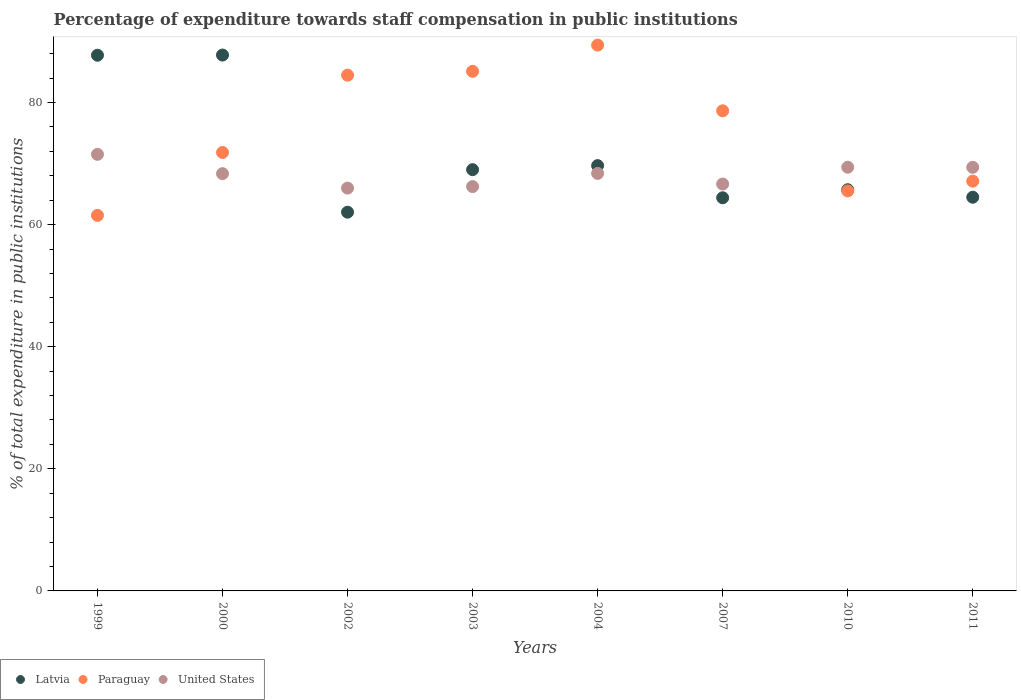How many different coloured dotlines are there?
Your response must be concise. 3. What is the percentage of expenditure towards staff compensation in Latvia in 1999?
Offer a very short reply. 87.75. Across all years, what is the maximum percentage of expenditure towards staff compensation in United States?
Your answer should be compact. 71.52. Across all years, what is the minimum percentage of expenditure towards staff compensation in Paraguay?
Keep it short and to the point. 61.52. In which year was the percentage of expenditure towards staff compensation in Latvia maximum?
Your response must be concise. 2000. In which year was the percentage of expenditure towards staff compensation in United States minimum?
Keep it short and to the point. 2002. What is the total percentage of expenditure towards staff compensation in Paraguay in the graph?
Your response must be concise. 603.67. What is the difference between the percentage of expenditure towards staff compensation in United States in 2004 and that in 2011?
Make the answer very short. -1. What is the difference between the percentage of expenditure towards staff compensation in Paraguay in 2000 and the percentage of expenditure towards staff compensation in Latvia in 2007?
Keep it short and to the point. 7.42. What is the average percentage of expenditure towards staff compensation in Paraguay per year?
Your response must be concise. 75.46. In the year 2002, what is the difference between the percentage of expenditure towards staff compensation in Paraguay and percentage of expenditure towards staff compensation in Latvia?
Offer a terse response. 22.44. What is the ratio of the percentage of expenditure towards staff compensation in Paraguay in 2003 to that in 2011?
Make the answer very short. 1.27. What is the difference between the highest and the second highest percentage of expenditure towards staff compensation in United States?
Your answer should be compact. 2.11. What is the difference between the highest and the lowest percentage of expenditure towards staff compensation in United States?
Provide a short and direct response. 5.53. In how many years, is the percentage of expenditure towards staff compensation in Latvia greater than the average percentage of expenditure towards staff compensation in Latvia taken over all years?
Make the answer very short. 2. Is it the case that in every year, the sum of the percentage of expenditure towards staff compensation in United States and percentage of expenditure towards staff compensation in Paraguay  is greater than the percentage of expenditure towards staff compensation in Latvia?
Offer a very short reply. Yes. Is the percentage of expenditure towards staff compensation in Paraguay strictly greater than the percentage of expenditure towards staff compensation in Latvia over the years?
Offer a terse response. No. How many dotlines are there?
Keep it short and to the point. 3. How many years are there in the graph?
Give a very brief answer. 8. What is the difference between two consecutive major ticks on the Y-axis?
Provide a short and direct response. 20. Are the values on the major ticks of Y-axis written in scientific E-notation?
Make the answer very short. No. Does the graph contain any zero values?
Your response must be concise. No. Where does the legend appear in the graph?
Your response must be concise. Bottom left. How are the legend labels stacked?
Your response must be concise. Horizontal. What is the title of the graph?
Provide a succinct answer. Percentage of expenditure towards staff compensation in public institutions. Does "Afghanistan" appear as one of the legend labels in the graph?
Give a very brief answer. No. What is the label or title of the Y-axis?
Offer a terse response. % of total expenditure in public institutions. What is the % of total expenditure in public institutions of Latvia in 1999?
Your answer should be compact. 87.75. What is the % of total expenditure in public institutions in Paraguay in 1999?
Offer a terse response. 61.52. What is the % of total expenditure in public institutions of United States in 1999?
Offer a terse response. 71.52. What is the % of total expenditure in public institutions in Latvia in 2000?
Keep it short and to the point. 87.78. What is the % of total expenditure in public institutions of Paraguay in 2000?
Your answer should be very brief. 71.82. What is the % of total expenditure in public institutions of United States in 2000?
Your answer should be compact. 68.35. What is the % of total expenditure in public institutions in Latvia in 2002?
Keep it short and to the point. 62.04. What is the % of total expenditure in public institutions in Paraguay in 2002?
Provide a short and direct response. 84.49. What is the % of total expenditure in public institutions in United States in 2002?
Make the answer very short. 65.98. What is the % of total expenditure in public institutions in Latvia in 2003?
Provide a succinct answer. 69.01. What is the % of total expenditure in public institutions in Paraguay in 2003?
Ensure brevity in your answer.  85.12. What is the % of total expenditure in public institutions of United States in 2003?
Make the answer very short. 66.24. What is the % of total expenditure in public institutions of Latvia in 2004?
Provide a succinct answer. 69.67. What is the % of total expenditure in public institutions in Paraguay in 2004?
Give a very brief answer. 89.41. What is the % of total expenditure in public institutions in United States in 2004?
Provide a succinct answer. 68.39. What is the % of total expenditure in public institutions of Latvia in 2007?
Offer a terse response. 64.4. What is the % of total expenditure in public institutions of Paraguay in 2007?
Offer a very short reply. 78.65. What is the % of total expenditure in public institutions in United States in 2007?
Offer a terse response. 66.65. What is the % of total expenditure in public institutions of Latvia in 2010?
Give a very brief answer. 65.72. What is the % of total expenditure in public institutions of Paraguay in 2010?
Offer a terse response. 65.53. What is the % of total expenditure in public institutions in United States in 2010?
Provide a short and direct response. 69.4. What is the % of total expenditure in public institutions of Latvia in 2011?
Provide a short and direct response. 64.49. What is the % of total expenditure in public institutions in Paraguay in 2011?
Provide a short and direct response. 67.13. What is the % of total expenditure in public institutions of United States in 2011?
Give a very brief answer. 69.39. Across all years, what is the maximum % of total expenditure in public institutions in Latvia?
Your response must be concise. 87.78. Across all years, what is the maximum % of total expenditure in public institutions in Paraguay?
Make the answer very short. 89.41. Across all years, what is the maximum % of total expenditure in public institutions of United States?
Your answer should be very brief. 71.52. Across all years, what is the minimum % of total expenditure in public institutions in Latvia?
Make the answer very short. 62.04. Across all years, what is the minimum % of total expenditure in public institutions of Paraguay?
Provide a succinct answer. 61.52. Across all years, what is the minimum % of total expenditure in public institutions of United States?
Your answer should be compact. 65.98. What is the total % of total expenditure in public institutions of Latvia in the graph?
Keep it short and to the point. 570.88. What is the total % of total expenditure in public institutions of Paraguay in the graph?
Provide a succinct answer. 603.67. What is the total % of total expenditure in public institutions in United States in the graph?
Provide a succinct answer. 545.93. What is the difference between the % of total expenditure in public institutions of Latvia in 1999 and that in 2000?
Make the answer very short. -0.03. What is the difference between the % of total expenditure in public institutions in Paraguay in 1999 and that in 2000?
Make the answer very short. -10.3. What is the difference between the % of total expenditure in public institutions in United States in 1999 and that in 2000?
Your answer should be compact. 3.16. What is the difference between the % of total expenditure in public institutions of Latvia in 1999 and that in 2002?
Give a very brief answer. 25.71. What is the difference between the % of total expenditure in public institutions in Paraguay in 1999 and that in 2002?
Provide a succinct answer. -22.97. What is the difference between the % of total expenditure in public institutions of United States in 1999 and that in 2002?
Give a very brief answer. 5.53. What is the difference between the % of total expenditure in public institutions of Latvia in 1999 and that in 2003?
Ensure brevity in your answer.  18.74. What is the difference between the % of total expenditure in public institutions in Paraguay in 1999 and that in 2003?
Ensure brevity in your answer.  -23.6. What is the difference between the % of total expenditure in public institutions in United States in 1999 and that in 2003?
Offer a very short reply. 5.28. What is the difference between the % of total expenditure in public institutions in Latvia in 1999 and that in 2004?
Offer a very short reply. 18.08. What is the difference between the % of total expenditure in public institutions in Paraguay in 1999 and that in 2004?
Your answer should be very brief. -27.9. What is the difference between the % of total expenditure in public institutions of United States in 1999 and that in 2004?
Your response must be concise. 3.12. What is the difference between the % of total expenditure in public institutions of Latvia in 1999 and that in 2007?
Keep it short and to the point. 23.35. What is the difference between the % of total expenditure in public institutions of Paraguay in 1999 and that in 2007?
Keep it short and to the point. -17.13. What is the difference between the % of total expenditure in public institutions of United States in 1999 and that in 2007?
Keep it short and to the point. 4.86. What is the difference between the % of total expenditure in public institutions in Latvia in 1999 and that in 2010?
Offer a very short reply. 22.03. What is the difference between the % of total expenditure in public institutions of Paraguay in 1999 and that in 2010?
Make the answer very short. -4.01. What is the difference between the % of total expenditure in public institutions of United States in 1999 and that in 2010?
Ensure brevity in your answer.  2.11. What is the difference between the % of total expenditure in public institutions in Latvia in 1999 and that in 2011?
Ensure brevity in your answer.  23.26. What is the difference between the % of total expenditure in public institutions in Paraguay in 1999 and that in 2011?
Offer a terse response. -5.61. What is the difference between the % of total expenditure in public institutions in United States in 1999 and that in 2011?
Your response must be concise. 2.12. What is the difference between the % of total expenditure in public institutions in Latvia in 2000 and that in 2002?
Keep it short and to the point. 25.74. What is the difference between the % of total expenditure in public institutions of Paraguay in 2000 and that in 2002?
Offer a very short reply. -12.67. What is the difference between the % of total expenditure in public institutions of United States in 2000 and that in 2002?
Your answer should be very brief. 2.37. What is the difference between the % of total expenditure in public institutions in Latvia in 2000 and that in 2003?
Offer a very short reply. 18.77. What is the difference between the % of total expenditure in public institutions of Paraguay in 2000 and that in 2003?
Give a very brief answer. -13.3. What is the difference between the % of total expenditure in public institutions of United States in 2000 and that in 2003?
Make the answer very short. 2.11. What is the difference between the % of total expenditure in public institutions in Latvia in 2000 and that in 2004?
Provide a short and direct response. 18.11. What is the difference between the % of total expenditure in public institutions in Paraguay in 2000 and that in 2004?
Provide a short and direct response. -17.59. What is the difference between the % of total expenditure in public institutions of United States in 2000 and that in 2004?
Keep it short and to the point. -0.04. What is the difference between the % of total expenditure in public institutions in Latvia in 2000 and that in 2007?
Your response must be concise. 23.38. What is the difference between the % of total expenditure in public institutions of Paraguay in 2000 and that in 2007?
Your answer should be compact. -6.83. What is the difference between the % of total expenditure in public institutions in United States in 2000 and that in 2007?
Offer a very short reply. 1.7. What is the difference between the % of total expenditure in public institutions in Latvia in 2000 and that in 2010?
Make the answer very short. 22.06. What is the difference between the % of total expenditure in public institutions of Paraguay in 2000 and that in 2010?
Offer a terse response. 6.29. What is the difference between the % of total expenditure in public institutions in United States in 2000 and that in 2010?
Provide a succinct answer. -1.05. What is the difference between the % of total expenditure in public institutions of Latvia in 2000 and that in 2011?
Make the answer very short. 23.29. What is the difference between the % of total expenditure in public institutions in Paraguay in 2000 and that in 2011?
Give a very brief answer. 4.69. What is the difference between the % of total expenditure in public institutions in United States in 2000 and that in 2011?
Your answer should be very brief. -1.04. What is the difference between the % of total expenditure in public institutions of Latvia in 2002 and that in 2003?
Give a very brief answer. -6.97. What is the difference between the % of total expenditure in public institutions of Paraguay in 2002 and that in 2003?
Offer a very short reply. -0.63. What is the difference between the % of total expenditure in public institutions of United States in 2002 and that in 2003?
Offer a terse response. -0.25. What is the difference between the % of total expenditure in public institutions of Latvia in 2002 and that in 2004?
Your answer should be very brief. -7.63. What is the difference between the % of total expenditure in public institutions of Paraguay in 2002 and that in 2004?
Provide a short and direct response. -4.93. What is the difference between the % of total expenditure in public institutions of United States in 2002 and that in 2004?
Provide a succinct answer. -2.41. What is the difference between the % of total expenditure in public institutions of Latvia in 2002 and that in 2007?
Offer a very short reply. -2.36. What is the difference between the % of total expenditure in public institutions in Paraguay in 2002 and that in 2007?
Provide a short and direct response. 5.84. What is the difference between the % of total expenditure in public institutions in United States in 2002 and that in 2007?
Ensure brevity in your answer.  -0.67. What is the difference between the % of total expenditure in public institutions of Latvia in 2002 and that in 2010?
Keep it short and to the point. -3.68. What is the difference between the % of total expenditure in public institutions in Paraguay in 2002 and that in 2010?
Keep it short and to the point. 18.96. What is the difference between the % of total expenditure in public institutions of United States in 2002 and that in 2010?
Provide a succinct answer. -3.42. What is the difference between the % of total expenditure in public institutions in Latvia in 2002 and that in 2011?
Your response must be concise. -2.45. What is the difference between the % of total expenditure in public institutions in Paraguay in 2002 and that in 2011?
Provide a succinct answer. 17.36. What is the difference between the % of total expenditure in public institutions of United States in 2002 and that in 2011?
Offer a very short reply. -3.41. What is the difference between the % of total expenditure in public institutions of Latvia in 2003 and that in 2004?
Make the answer very short. -0.66. What is the difference between the % of total expenditure in public institutions in Paraguay in 2003 and that in 2004?
Keep it short and to the point. -4.3. What is the difference between the % of total expenditure in public institutions in United States in 2003 and that in 2004?
Offer a very short reply. -2.16. What is the difference between the % of total expenditure in public institutions in Latvia in 2003 and that in 2007?
Your answer should be compact. 4.61. What is the difference between the % of total expenditure in public institutions of Paraguay in 2003 and that in 2007?
Make the answer very short. 6.47. What is the difference between the % of total expenditure in public institutions of United States in 2003 and that in 2007?
Your answer should be compact. -0.42. What is the difference between the % of total expenditure in public institutions in Latvia in 2003 and that in 2010?
Keep it short and to the point. 3.29. What is the difference between the % of total expenditure in public institutions in Paraguay in 2003 and that in 2010?
Keep it short and to the point. 19.59. What is the difference between the % of total expenditure in public institutions of United States in 2003 and that in 2010?
Ensure brevity in your answer.  -3.17. What is the difference between the % of total expenditure in public institutions of Latvia in 2003 and that in 2011?
Offer a terse response. 4.52. What is the difference between the % of total expenditure in public institutions of Paraguay in 2003 and that in 2011?
Offer a very short reply. 17.99. What is the difference between the % of total expenditure in public institutions in United States in 2003 and that in 2011?
Provide a short and direct response. -3.15. What is the difference between the % of total expenditure in public institutions in Latvia in 2004 and that in 2007?
Offer a terse response. 5.27. What is the difference between the % of total expenditure in public institutions in Paraguay in 2004 and that in 2007?
Provide a succinct answer. 10.76. What is the difference between the % of total expenditure in public institutions in United States in 2004 and that in 2007?
Keep it short and to the point. 1.74. What is the difference between the % of total expenditure in public institutions of Latvia in 2004 and that in 2010?
Provide a short and direct response. 3.95. What is the difference between the % of total expenditure in public institutions in Paraguay in 2004 and that in 2010?
Give a very brief answer. 23.89. What is the difference between the % of total expenditure in public institutions of United States in 2004 and that in 2010?
Your answer should be very brief. -1.01. What is the difference between the % of total expenditure in public institutions of Latvia in 2004 and that in 2011?
Your answer should be very brief. 5.18. What is the difference between the % of total expenditure in public institutions in Paraguay in 2004 and that in 2011?
Offer a very short reply. 22.29. What is the difference between the % of total expenditure in public institutions in United States in 2004 and that in 2011?
Offer a very short reply. -1. What is the difference between the % of total expenditure in public institutions in Latvia in 2007 and that in 2010?
Offer a terse response. -1.32. What is the difference between the % of total expenditure in public institutions in Paraguay in 2007 and that in 2010?
Your response must be concise. 13.12. What is the difference between the % of total expenditure in public institutions in United States in 2007 and that in 2010?
Keep it short and to the point. -2.75. What is the difference between the % of total expenditure in public institutions in Latvia in 2007 and that in 2011?
Provide a succinct answer. -0.09. What is the difference between the % of total expenditure in public institutions in Paraguay in 2007 and that in 2011?
Provide a succinct answer. 11.52. What is the difference between the % of total expenditure in public institutions of United States in 2007 and that in 2011?
Make the answer very short. -2.74. What is the difference between the % of total expenditure in public institutions of Latvia in 2010 and that in 2011?
Keep it short and to the point. 1.23. What is the difference between the % of total expenditure in public institutions in Paraguay in 2010 and that in 2011?
Your answer should be very brief. -1.6. What is the difference between the % of total expenditure in public institutions in United States in 2010 and that in 2011?
Your answer should be compact. 0.01. What is the difference between the % of total expenditure in public institutions in Latvia in 1999 and the % of total expenditure in public institutions in Paraguay in 2000?
Provide a succinct answer. 15.93. What is the difference between the % of total expenditure in public institutions of Latvia in 1999 and the % of total expenditure in public institutions of United States in 2000?
Your answer should be very brief. 19.4. What is the difference between the % of total expenditure in public institutions of Paraguay in 1999 and the % of total expenditure in public institutions of United States in 2000?
Offer a very short reply. -6.83. What is the difference between the % of total expenditure in public institutions of Latvia in 1999 and the % of total expenditure in public institutions of Paraguay in 2002?
Offer a terse response. 3.27. What is the difference between the % of total expenditure in public institutions of Latvia in 1999 and the % of total expenditure in public institutions of United States in 2002?
Give a very brief answer. 21.77. What is the difference between the % of total expenditure in public institutions of Paraguay in 1999 and the % of total expenditure in public institutions of United States in 2002?
Offer a terse response. -4.47. What is the difference between the % of total expenditure in public institutions in Latvia in 1999 and the % of total expenditure in public institutions in Paraguay in 2003?
Keep it short and to the point. 2.64. What is the difference between the % of total expenditure in public institutions in Latvia in 1999 and the % of total expenditure in public institutions in United States in 2003?
Give a very brief answer. 21.52. What is the difference between the % of total expenditure in public institutions of Paraguay in 1999 and the % of total expenditure in public institutions of United States in 2003?
Give a very brief answer. -4.72. What is the difference between the % of total expenditure in public institutions in Latvia in 1999 and the % of total expenditure in public institutions in Paraguay in 2004?
Provide a succinct answer. -1.66. What is the difference between the % of total expenditure in public institutions in Latvia in 1999 and the % of total expenditure in public institutions in United States in 2004?
Offer a very short reply. 19.36. What is the difference between the % of total expenditure in public institutions of Paraguay in 1999 and the % of total expenditure in public institutions of United States in 2004?
Give a very brief answer. -6.88. What is the difference between the % of total expenditure in public institutions in Latvia in 1999 and the % of total expenditure in public institutions in Paraguay in 2007?
Ensure brevity in your answer.  9.1. What is the difference between the % of total expenditure in public institutions of Latvia in 1999 and the % of total expenditure in public institutions of United States in 2007?
Your answer should be very brief. 21.1. What is the difference between the % of total expenditure in public institutions in Paraguay in 1999 and the % of total expenditure in public institutions in United States in 2007?
Provide a short and direct response. -5.14. What is the difference between the % of total expenditure in public institutions in Latvia in 1999 and the % of total expenditure in public institutions in Paraguay in 2010?
Offer a very short reply. 22.23. What is the difference between the % of total expenditure in public institutions in Latvia in 1999 and the % of total expenditure in public institutions in United States in 2010?
Your answer should be very brief. 18.35. What is the difference between the % of total expenditure in public institutions in Paraguay in 1999 and the % of total expenditure in public institutions in United States in 2010?
Give a very brief answer. -7.89. What is the difference between the % of total expenditure in public institutions of Latvia in 1999 and the % of total expenditure in public institutions of Paraguay in 2011?
Your answer should be compact. 20.63. What is the difference between the % of total expenditure in public institutions in Latvia in 1999 and the % of total expenditure in public institutions in United States in 2011?
Make the answer very short. 18.36. What is the difference between the % of total expenditure in public institutions in Paraguay in 1999 and the % of total expenditure in public institutions in United States in 2011?
Offer a very short reply. -7.87. What is the difference between the % of total expenditure in public institutions of Latvia in 2000 and the % of total expenditure in public institutions of Paraguay in 2002?
Offer a very short reply. 3.3. What is the difference between the % of total expenditure in public institutions in Latvia in 2000 and the % of total expenditure in public institutions in United States in 2002?
Keep it short and to the point. 21.8. What is the difference between the % of total expenditure in public institutions in Paraguay in 2000 and the % of total expenditure in public institutions in United States in 2002?
Provide a succinct answer. 5.84. What is the difference between the % of total expenditure in public institutions in Latvia in 2000 and the % of total expenditure in public institutions in Paraguay in 2003?
Your answer should be very brief. 2.67. What is the difference between the % of total expenditure in public institutions in Latvia in 2000 and the % of total expenditure in public institutions in United States in 2003?
Provide a short and direct response. 21.55. What is the difference between the % of total expenditure in public institutions of Paraguay in 2000 and the % of total expenditure in public institutions of United States in 2003?
Your answer should be very brief. 5.58. What is the difference between the % of total expenditure in public institutions of Latvia in 2000 and the % of total expenditure in public institutions of Paraguay in 2004?
Offer a very short reply. -1.63. What is the difference between the % of total expenditure in public institutions of Latvia in 2000 and the % of total expenditure in public institutions of United States in 2004?
Keep it short and to the point. 19.39. What is the difference between the % of total expenditure in public institutions of Paraguay in 2000 and the % of total expenditure in public institutions of United States in 2004?
Give a very brief answer. 3.43. What is the difference between the % of total expenditure in public institutions of Latvia in 2000 and the % of total expenditure in public institutions of Paraguay in 2007?
Your answer should be very brief. 9.13. What is the difference between the % of total expenditure in public institutions of Latvia in 2000 and the % of total expenditure in public institutions of United States in 2007?
Your response must be concise. 21.13. What is the difference between the % of total expenditure in public institutions in Paraguay in 2000 and the % of total expenditure in public institutions in United States in 2007?
Make the answer very short. 5.17. What is the difference between the % of total expenditure in public institutions of Latvia in 2000 and the % of total expenditure in public institutions of Paraguay in 2010?
Your response must be concise. 22.26. What is the difference between the % of total expenditure in public institutions of Latvia in 2000 and the % of total expenditure in public institutions of United States in 2010?
Your answer should be compact. 18.38. What is the difference between the % of total expenditure in public institutions in Paraguay in 2000 and the % of total expenditure in public institutions in United States in 2010?
Provide a short and direct response. 2.42. What is the difference between the % of total expenditure in public institutions of Latvia in 2000 and the % of total expenditure in public institutions of Paraguay in 2011?
Keep it short and to the point. 20.65. What is the difference between the % of total expenditure in public institutions in Latvia in 2000 and the % of total expenditure in public institutions in United States in 2011?
Keep it short and to the point. 18.39. What is the difference between the % of total expenditure in public institutions in Paraguay in 2000 and the % of total expenditure in public institutions in United States in 2011?
Offer a terse response. 2.43. What is the difference between the % of total expenditure in public institutions of Latvia in 2002 and the % of total expenditure in public institutions of Paraguay in 2003?
Make the answer very short. -23.07. What is the difference between the % of total expenditure in public institutions of Latvia in 2002 and the % of total expenditure in public institutions of United States in 2003?
Your answer should be very brief. -4.19. What is the difference between the % of total expenditure in public institutions in Paraguay in 2002 and the % of total expenditure in public institutions in United States in 2003?
Your answer should be very brief. 18.25. What is the difference between the % of total expenditure in public institutions in Latvia in 2002 and the % of total expenditure in public institutions in Paraguay in 2004?
Offer a very short reply. -27.37. What is the difference between the % of total expenditure in public institutions in Latvia in 2002 and the % of total expenditure in public institutions in United States in 2004?
Keep it short and to the point. -6.35. What is the difference between the % of total expenditure in public institutions of Paraguay in 2002 and the % of total expenditure in public institutions of United States in 2004?
Provide a short and direct response. 16.09. What is the difference between the % of total expenditure in public institutions in Latvia in 2002 and the % of total expenditure in public institutions in Paraguay in 2007?
Keep it short and to the point. -16.61. What is the difference between the % of total expenditure in public institutions in Latvia in 2002 and the % of total expenditure in public institutions in United States in 2007?
Provide a short and direct response. -4.61. What is the difference between the % of total expenditure in public institutions of Paraguay in 2002 and the % of total expenditure in public institutions of United States in 2007?
Ensure brevity in your answer.  17.84. What is the difference between the % of total expenditure in public institutions of Latvia in 2002 and the % of total expenditure in public institutions of Paraguay in 2010?
Offer a terse response. -3.48. What is the difference between the % of total expenditure in public institutions of Latvia in 2002 and the % of total expenditure in public institutions of United States in 2010?
Your response must be concise. -7.36. What is the difference between the % of total expenditure in public institutions of Paraguay in 2002 and the % of total expenditure in public institutions of United States in 2010?
Offer a very short reply. 15.08. What is the difference between the % of total expenditure in public institutions of Latvia in 2002 and the % of total expenditure in public institutions of Paraguay in 2011?
Provide a succinct answer. -5.08. What is the difference between the % of total expenditure in public institutions of Latvia in 2002 and the % of total expenditure in public institutions of United States in 2011?
Offer a very short reply. -7.35. What is the difference between the % of total expenditure in public institutions of Paraguay in 2002 and the % of total expenditure in public institutions of United States in 2011?
Keep it short and to the point. 15.1. What is the difference between the % of total expenditure in public institutions of Latvia in 2003 and the % of total expenditure in public institutions of Paraguay in 2004?
Offer a terse response. -20.41. What is the difference between the % of total expenditure in public institutions in Latvia in 2003 and the % of total expenditure in public institutions in United States in 2004?
Your response must be concise. 0.61. What is the difference between the % of total expenditure in public institutions of Paraguay in 2003 and the % of total expenditure in public institutions of United States in 2004?
Provide a succinct answer. 16.72. What is the difference between the % of total expenditure in public institutions in Latvia in 2003 and the % of total expenditure in public institutions in Paraguay in 2007?
Provide a succinct answer. -9.64. What is the difference between the % of total expenditure in public institutions of Latvia in 2003 and the % of total expenditure in public institutions of United States in 2007?
Provide a short and direct response. 2.36. What is the difference between the % of total expenditure in public institutions in Paraguay in 2003 and the % of total expenditure in public institutions in United States in 2007?
Make the answer very short. 18.46. What is the difference between the % of total expenditure in public institutions of Latvia in 2003 and the % of total expenditure in public institutions of Paraguay in 2010?
Ensure brevity in your answer.  3.48. What is the difference between the % of total expenditure in public institutions in Latvia in 2003 and the % of total expenditure in public institutions in United States in 2010?
Offer a terse response. -0.4. What is the difference between the % of total expenditure in public institutions in Paraguay in 2003 and the % of total expenditure in public institutions in United States in 2010?
Ensure brevity in your answer.  15.71. What is the difference between the % of total expenditure in public institutions in Latvia in 2003 and the % of total expenditure in public institutions in Paraguay in 2011?
Offer a terse response. 1.88. What is the difference between the % of total expenditure in public institutions of Latvia in 2003 and the % of total expenditure in public institutions of United States in 2011?
Provide a short and direct response. -0.38. What is the difference between the % of total expenditure in public institutions of Paraguay in 2003 and the % of total expenditure in public institutions of United States in 2011?
Your answer should be compact. 15.73. What is the difference between the % of total expenditure in public institutions in Latvia in 2004 and the % of total expenditure in public institutions in Paraguay in 2007?
Ensure brevity in your answer.  -8.98. What is the difference between the % of total expenditure in public institutions of Latvia in 2004 and the % of total expenditure in public institutions of United States in 2007?
Make the answer very short. 3.02. What is the difference between the % of total expenditure in public institutions of Paraguay in 2004 and the % of total expenditure in public institutions of United States in 2007?
Your response must be concise. 22.76. What is the difference between the % of total expenditure in public institutions in Latvia in 2004 and the % of total expenditure in public institutions in Paraguay in 2010?
Offer a very short reply. 4.14. What is the difference between the % of total expenditure in public institutions of Latvia in 2004 and the % of total expenditure in public institutions of United States in 2010?
Give a very brief answer. 0.27. What is the difference between the % of total expenditure in public institutions of Paraguay in 2004 and the % of total expenditure in public institutions of United States in 2010?
Ensure brevity in your answer.  20.01. What is the difference between the % of total expenditure in public institutions of Latvia in 2004 and the % of total expenditure in public institutions of Paraguay in 2011?
Make the answer very short. 2.54. What is the difference between the % of total expenditure in public institutions in Latvia in 2004 and the % of total expenditure in public institutions in United States in 2011?
Ensure brevity in your answer.  0.28. What is the difference between the % of total expenditure in public institutions of Paraguay in 2004 and the % of total expenditure in public institutions of United States in 2011?
Offer a very short reply. 20.02. What is the difference between the % of total expenditure in public institutions in Latvia in 2007 and the % of total expenditure in public institutions in Paraguay in 2010?
Make the answer very short. -1.12. What is the difference between the % of total expenditure in public institutions in Latvia in 2007 and the % of total expenditure in public institutions in United States in 2010?
Your answer should be very brief. -5. What is the difference between the % of total expenditure in public institutions of Paraguay in 2007 and the % of total expenditure in public institutions of United States in 2010?
Keep it short and to the point. 9.25. What is the difference between the % of total expenditure in public institutions of Latvia in 2007 and the % of total expenditure in public institutions of Paraguay in 2011?
Your response must be concise. -2.73. What is the difference between the % of total expenditure in public institutions in Latvia in 2007 and the % of total expenditure in public institutions in United States in 2011?
Provide a short and direct response. -4.99. What is the difference between the % of total expenditure in public institutions in Paraguay in 2007 and the % of total expenditure in public institutions in United States in 2011?
Offer a terse response. 9.26. What is the difference between the % of total expenditure in public institutions of Latvia in 2010 and the % of total expenditure in public institutions of Paraguay in 2011?
Your answer should be compact. -1.41. What is the difference between the % of total expenditure in public institutions in Latvia in 2010 and the % of total expenditure in public institutions in United States in 2011?
Your answer should be compact. -3.67. What is the difference between the % of total expenditure in public institutions of Paraguay in 2010 and the % of total expenditure in public institutions of United States in 2011?
Your answer should be compact. -3.86. What is the average % of total expenditure in public institutions of Latvia per year?
Provide a succinct answer. 71.36. What is the average % of total expenditure in public institutions of Paraguay per year?
Keep it short and to the point. 75.46. What is the average % of total expenditure in public institutions in United States per year?
Offer a very short reply. 68.24. In the year 1999, what is the difference between the % of total expenditure in public institutions in Latvia and % of total expenditure in public institutions in Paraguay?
Your answer should be compact. 26.24. In the year 1999, what is the difference between the % of total expenditure in public institutions in Latvia and % of total expenditure in public institutions in United States?
Provide a short and direct response. 16.24. In the year 1999, what is the difference between the % of total expenditure in public institutions of Paraguay and % of total expenditure in public institutions of United States?
Your response must be concise. -10. In the year 2000, what is the difference between the % of total expenditure in public institutions in Latvia and % of total expenditure in public institutions in Paraguay?
Your answer should be very brief. 15.96. In the year 2000, what is the difference between the % of total expenditure in public institutions of Latvia and % of total expenditure in public institutions of United States?
Make the answer very short. 19.43. In the year 2000, what is the difference between the % of total expenditure in public institutions in Paraguay and % of total expenditure in public institutions in United States?
Keep it short and to the point. 3.47. In the year 2002, what is the difference between the % of total expenditure in public institutions in Latvia and % of total expenditure in public institutions in Paraguay?
Your response must be concise. -22.44. In the year 2002, what is the difference between the % of total expenditure in public institutions of Latvia and % of total expenditure in public institutions of United States?
Provide a short and direct response. -3.94. In the year 2002, what is the difference between the % of total expenditure in public institutions of Paraguay and % of total expenditure in public institutions of United States?
Your answer should be very brief. 18.5. In the year 2003, what is the difference between the % of total expenditure in public institutions in Latvia and % of total expenditure in public institutions in Paraguay?
Offer a terse response. -16.11. In the year 2003, what is the difference between the % of total expenditure in public institutions in Latvia and % of total expenditure in public institutions in United States?
Offer a terse response. 2.77. In the year 2003, what is the difference between the % of total expenditure in public institutions of Paraguay and % of total expenditure in public institutions of United States?
Make the answer very short. 18.88. In the year 2004, what is the difference between the % of total expenditure in public institutions in Latvia and % of total expenditure in public institutions in Paraguay?
Give a very brief answer. -19.74. In the year 2004, what is the difference between the % of total expenditure in public institutions in Latvia and % of total expenditure in public institutions in United States?
Give a very brief answer. 1.28. In the year 2004, what is the difference between the % of total expenditure in public institutions of Paraguay and % of total expenditure in public institutions of United States?
Ensure brevity in your answer.  21.02. In the year 2007, what is the difference between the % of total expenditure in public institutions in Latvia and % of total expenditure in public institutions in Paraguay?
Make the answer very short. -14.25. In the year 2007, what is the difference between the % of total expenditure in public institutions in Latvia and % of total expenditure in public institutions in United States?
Make the answer very short. -2.25. In the year 2007, what is the difference between the % of total expenditure in public institutions of Paraguay and % of total expenditure in public institutions of United States?
Offer a terse response. 12. In the year 2010, what is the difference between the % of total expenditure in public institutions in Latvia and % of total expenditure in public institutions in Paraguay?
Your answer should be compact. 0.19. In the year 2010, what is the difference between the % of total expenditure in public institutions of Latvia and % of total expenditure in public institutions of United States?
Provide a short and direct response. -3.68. In the year 2010, what is the difference between the % of total expenditure in public institutions in Paraguay and % of total expenditure in public institutions in United States?
Give a very brief answer. -3.88. In the year 2011, what is the difference between the % of total expenditure in public institutions of Latvia and % of total expenditure in public institutions of Paraguay?
Offer a terse response. -2.64. In the year 2011, what is the difference between the % of total expenditure in public institutions of Latvia and % of total expenditure in public institutions of United States?
Provide a succinct answer. -4.9. In the year 2011, what is the difference between the % of total expenditure in public institutions in Paraguay and % of total expenditure in public institutions in United States?
Your answer should be compact. -2.26. What is the ratio of the % of total expenditure in public institutions in Paraguay in 1999 to that in 2000?
Your response must be concise. 0.86. What is the ratio of the % of total expenditure in public institutions in United States in 1999 to that in 2000?
Provide a short and direct response. 1.05. What is the ratio of the % of total expenditure in public institutions in Latvia in 1999 to that in 2002?
Provide a short and direct response. 1.41. What is the ratio of the % of total expenditure in public institutions of Paraguay in 1999 to that in 2002?
Make the answer very short. 0.73. What is the ratio of the % of total expenditure in public institutions in United States in 1999 to that in 2002?
Offer a very short reply. 1.08. What is the ratio of the % of total expenditure in public institutions of Latvia in 1999 to that in 2003?
Provide a short and direct response. 1.27. What is the ratio of the % of total expenditure in public institutions of Paraguay in 1999 to that in 2003?
Ensure brevity in your answer.  0.72. What is the ratio of the % of total expenditure in public institutions of United States in 1999 to that in 2003?
Give a very brief answer. 1.08. What is the ratio of the % of total expenditure in public institutions of Latvia in 1999 to that in 2004?
Make the answer very short. 1.26. What is the ratio of the % of total expenditure in public institutions in Paraguay in 1999 to that in 2004?
Give a very brief answer. 0.69. What is the ratio of the % of total expenditure in public institutions in United States in 1999 to that in 2004?
Give a very brief answer. 1.05. What is the ratio of the % of total expenditure in public institutions in Latvia in 1999 to that in 2007?
Your answer should be very brief. 1.36. What is the ratio of the % of total expenditure in public institutions of Paraguay in 1999 to that in 2007?
Offer a terse response. 0.78. What is the ratio of the % of total expenditure in public institutions in United States in 1999 to that in 2007?
Your answer should be compact. 1.07. What is the ratio of the % of total expenditure in public institutions in Latvia in 1999 to that in 2010?
Make the answer very short. 1.34. What is the ratio of the % of total expenditure in public institutions of Paraguay in 1999 to that in 2010?
Provide a short and direct response. 0.94. What is the ratio of the % of total expenditure in public institutions in United States in 1999 to that in 2010?
Your response must be concise. 1.03. What is the ratio of the % of total expenditure in public institutions of Latvia in 1999 to that in 2011?
Offer a terse response. 1.36. What is the ratio of the % of total expenditure in public institutions of Paraguay in 1999 to that in 2011?
Make the answer very short. 0.92. What is the ratio of the % of total expenditure in public institutions in United States in 1999 to that in 2011?
Offer a very short reply. 1.03. What is the ratio of the % of total expenditure in public institutions in Latvia in 2000 to that in 2002?
Ensure brevity in your answer.  1.41. What is the ratio of the % of total expenditure in public institutions in Paraguay in 2000 to that in 2002?
Provide a short and direct response. 0.85. What is the ratio of the % of total expenditure in public institutions of United States in 2000 to that in 2002?
Offer a terse response. 1.04. What is the ratio of the % of total expenditure in public institutions of Latvia in 2000 to that in 2003?
Ensure brevity in your answer.  1.27. What is the ratio of the % of total expenditure in public institutions in Paraguay in 2000 to that in 2003?
Ensure brevity in your answer.  0.84. What is the ratio of the % of total expenditure in public institutions of United States in 2000 to that in 2003?
Offer a terse response. 1.03. What is the ratio of the % of total expenditure in public institutions of Latvia in 2000 to that in 2004?
Your response must be concise. 1.26. What is the ratio of the % of total expenditure in public institutions in Paraguay in 2000 to that in 2004?
Give a very brief answer. 0.8. What is the ratio of the % of total expenditure in public institutions in Latvia in 2000 to that in 2007?
Your answer should be compact. 1.36. What is the ratio of the % of total expenditure in public institutions of Paraguay in 2000 to that in 2007?
Give a very brief answer. 0.91. What is the ratio of the % of total expenditure in public institutions of United States in 2000 to that in 2007?
Your answer should be compact. 1.03. What is the ratio of the % of total expenditure in public institutions in Latvia in 2000 to that in 2010?
Your response must be concise. 1.34. What is the ratio of the % of total expenditure in public institutions of Paraguay in 2000 to that in 2010?
Ensure brevity in your answer.  1.1. What is the ratio of the % of total expenditure in public institutions of Latvia in 2000 to that in 2011?
Offer a terse response. 1.36. What is the ratio of the % of total expenditure in public institutions of Paraguay in 2000 to that in 2011?
Keep it short and to the point. 1.07. What is the ratio of the % of total expenditure in public institutions in United States in 2000 to that in 2011?
Offer a very short reply. 0.98. What is the ratio of the % of total expenditure in public institutions of Latvia in 2002 to that in 2003?
Your answer should be compact. 0.9. What is the ratio of the % of total expenditure in public institutions in Paraguay in 2002 to that in 2003?
Keep it short and to the point. 0.99. What is the ratio of the % of total expenditure in public institutions of United States in 2002 to that in 2003?
Provide a short and direct response. 1. What is the ratio of the % of total expenditure in public institutions of Latvia in 2002 to that in 2004?
Provide a succinct answer. 0.89. What is the ratio of the % of total expenditure in public institutions of Paraguay in 2002 to that in 2004?
Make the answer very short. 0.94. What is the ratio of the % of total expenditure in public institutions in United States in 2002 to that in 2004?
Your response must be concise. 0.96. What is the ratio of the % of total expenditure in public institutions of Latvia in 2002 to that in 2007?
Make the answer very short. 0.96. What is the ratio of the % of total expenditure in public institutions in Paraguay in 2002 to that in 2007?
Ensure brevity in your answer.  1.07. What is the ratio of the % of total expenditure in public institutions in United States in 2002 to that in 2007?
Ensure brevity in your answer.  0.99. What is the ratio of the % of total expenditure in public institutions of Latvia in 2002 to that in 2010?
Your answer should be compact. 0.94. What is the ratio of the % of total expenditure in public institutions in Paraguay in 2002 to that in 2010?
Provide a succinct answer. 1.29. What is the ratio of the % of total expenditure in public institutions in United States in 2002 to that in 2010?
Your answer should be very brief. 0.95. What is the ratio of the % of total expenditure in public institutions of Paraguay in 2002 to that in 2011?
Ensure brevity in your answer.  1.26. What is the ratio of the % of total expenditure in public institutions in United States in 2002 to that in 2011?
Give a very brief answer. 0.95. What is the ratio of the % of total expenditure in public institutions in Latvia in 2003 to that in 2004?
Provide a succinct answer. 0.99. What is the ratio of the % of total expenditure in public institutions in Paraguay in 2003 to that in 2004?
Offer a very short reply. 0.95. What is the ratio of the % of total expenditure in public institutions of United States in 2003 to that in 2004?
Offer a terse response. 0.97. What is the ratio of the % of total expenditure in public institutions in Latvia in 2003 to that in 2007?
Provide a short and direct response. 1.07. What is the ratio of the % of total expenditure in public institutions of Paraguay in 2003 to that in 2007?
Provide a succinct answer. 1.08. What is the ratio of the % of total expenditure in public institutions in United States in 2003 to that in 2007?
Provide a succinct answer. 0.99. What is the ratio of the % of total expenditure in public institutions of Latvia in 2003 to that in 2010?
Make the answer very short. 1.05. What is the ratio of the % of total expenditure in public institutions in Paraguay in 2003 to that in 2010?
Your answer should be very brief. 1.3. What is the ratio of the % of total expenditure in public institutions of United States in 2003 to that in 2010?
Provide a short and direct response. 0.95. What is the ratio of the % of total expenditure in public institutions in Latvia in 2003 to that in 2011?
Your answer should be compact. 1.07. What is the ratio of the % of total expenditure in public institutions in Paraguay in 2003 to that in 2011?
Give a very brief answer. 1.27. What is the ratio of the % of total expenditure in public institutions of United States in 2003 to that in 2011?
Provide a short and direct response. 0.95. What is the ratio of the % of total expenditure in public institutions in Latvia in 2004 to that in 2007?
Your response must be concise. 1.08. What is the ratio of the % of total expenditure in public institutions in Paraguay in 2004 to that in 2007?
Provide a succinct answer. 1.14. What is the ratio of the % of total expenditure in public institutions of United States in 2004 to that in 2007?
Provide a succinct answer. 1.03. What is the ratio of the % of total expenditure in public institutions in Latvia in 2004 to that in 2010?
Offer a terse response. 1.06. What is the ratio of the % of total expenditure in public institutions of Paraguay in 2004 to that in 2010?
Provide a short and direct response. 1.36. What is the ratio of the % of total expenditure in public institutions in United States in 2004 to that in 2010?
Keep it short and to the point. 0.99. What is the ratio of the % of total expenditure in public institutions in Latvia in 2004 to that in 2011?
Your response must be concise. 1.08. What is the ratio of the % of total expenditure in public institutions in Paraguay in 2004 to that in 2011?
Your answer should be compact. 1.33. What is the ratio of the % of total expenditure in public institutions in United States in 2004 to that in 2011?
Give a very brief answer. 0.99. What is the ratio of the % of total expenditure in public institutions in Paraguay in 2007 to that in 2010?
Provide a short and direct response. 1.2. What is the ratio of the % of total expenditure in public institutions of United States in 2007 to that in 2010?
Your answer should be very brief. 0.96. What is the ratio of the % of total expenditure in public institutions in Latvia in 2007 to that in 2011?
Provide a succinct answer. 1. What is the ratio of the % of total expenditure in public institutions in Paraguay in 2007 to that in 2011?
Offer a very short reply. 1.17. What is the ratio of the % of total expenditure in public institutions of United States in 2007 to that in 2011?
Make the answer very short. 0.96. What is the ratio of the % of total expenditure in public institutions in Latvia in 2010 to that in 2011?
Ensure brevity in your answer.  1.02. What is the ratio of the % of total expenditure in public institutions in Paraguay in 2010 to that in 2011?
Provide a short and direct response. 0.98. What is the ratio of the % of total expenditure in public institutions of United States in 2010 to that in 2011?
Your response must be concise. 1. What is the difference between the highest and the second highest % of total expenditure in public institutions of Latvia?
Your answer should be compact. 0.03. What is the difference between the highest and the second highest % of total expenditure in public institutions in Paraguay?
Offer a very short reply. 4.3. What is the difference between the highest and the second highest % of total expenditure in public institutions in United States?
Your response must be concise. 2.11. What is the difference between the highest and the lowest % of total expenditure in public institutions of Latvia?
Keep it short and to the point. 25.74. What is the difference between the highest and the lowest % of total expenditure in public institutions in Paraguay?
Your response must be concise. 27.9. What is the difference between the highest and the lowest % of total expenditure in public institutions of United States?
Your response must be concise. 5.53. 